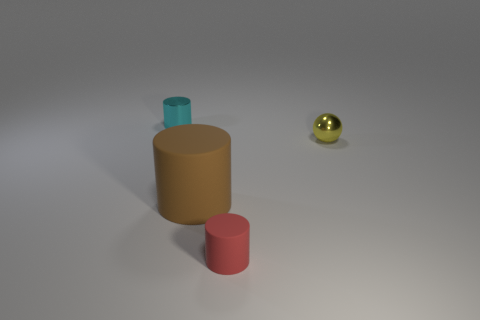Subtract all tiny cylinders. How many cylinders are left? 1 Subtract 1 balls. How many balls are left? 0 Add 3 red cylinders. How many objects exist? 7 Add 1 small balls. How many small balls are left? 2 Add 1 large gray metal cylinders. How many large gray metal cylinders exist? 1 Subtract 0 brown cubes. How many objects are left? 4 Subtract all cylinders. How many objects are left? 1 Subtract all purple cylinders. Subtract all blue balls. How many cylinders are left? 3 Subtract all red rubber objects. Subtract all brown cylinders. How many objects are left? 2 